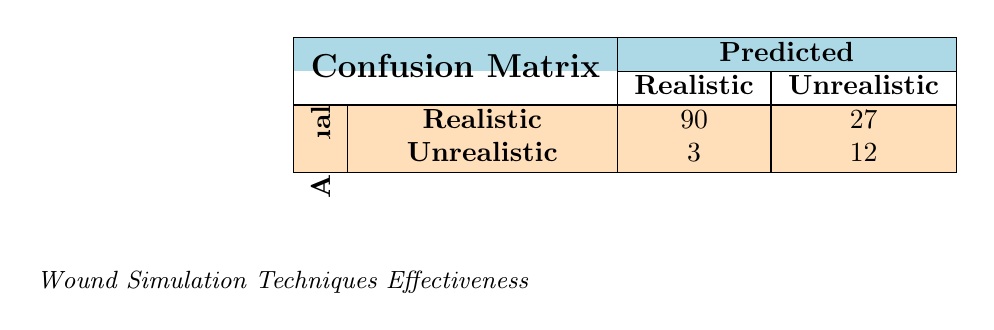What is the total number of instances where "Silicone Molding" was predicted as "Realistic"? From the table, we see that "Silicone Molding" has 25 instances with an actual outcome of "Realistic" and a predicted outcome of "Realistic". Therefore, the total number of instances where it was predicted as "Realistic" is 25.
Answer: 25 How many total predictions were made for the "Basic Special Effects" technique? The "Basic Special Effects" technique has 2 predictions: 3 for "Realistic" and 12 for "Unrealistic". Adding these gives us 3 + 12 = 15 total predictions.
Answer: 15 Is the count of instances for the "Advanced Wound Training" predicted as "Unrealistic" greater than that for "Gel-based Application"? "Advanced Wound Training" has 2 instances predicted as "Unrealistic", while "Gel-based Application" has 10 instances. Since 2 is not greater than 10, the statement is false.
Answer: No What percentage of "Simple Makeup" predictions were "Realistic"? "Simple Makeup" has 15 instances predicted as "Realistic" and 10 as "Unrealistic", totaling 25 predictions. To find the percentage: (15 / 25) * 100 = 60%.
Answer: 60% How many more instances were predicted correctly for "Realistic" outcomes compared to "Unrealistic" outcomes? For "Realistic" outcomes, there are 90 instances, while for "Unrealistic" outcomes, there are 27 instances. Finding the difference 90 - 27 = 63.
Answer: 63 What is the total count of unrealistic predictions across all techniques? We sum the instances under "Unrealistic" predictions: 5 (Silicone Molding) + 10 (Gel-based Application) + 10 (Simple Makeup) + 3 (Basic Special Effects) + 2 (Advanced Wound Training) = 40.
Answer: 40 Among the techniques listed, which has the highest count for realistic predictions? The highest count for realistic predictions in the table is 30 for "Advanced Wound Training."
Answer: Advanced Wound Training How many techniques had more instances predicted as "Unrealistic" compared to "Realistic"? Analyzing each technique's predictions, "Silicone Molding," "Gel-based Application," and "Simple Makeup" had more "Unrealistic" than "Realistic" predictions: 5 + 10 + 10 = 25 instances. Other techniques had less or equal counts. Thus, 3 techniques fit this criterion.
Answer: 3 